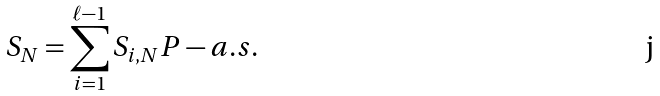Convert formula to latex. <formula><loc_0><loc_0><loc_500><loc_500>S _ { N } = \sum _ { i = 1 } ^ { \ell - 1 } S _ { i , N } P - a . s .</formula> 